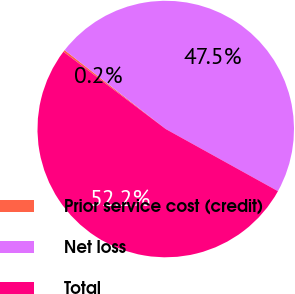<chart> <loc_0><loc_0><loc_500><loc_500><pie_chart><fcel>Prior service cost (credit)<fcel>Net loss<fcel>Total<nl><fcel>0.25%<fcel>47.5%<fcel>52.25%<nl></chart> 